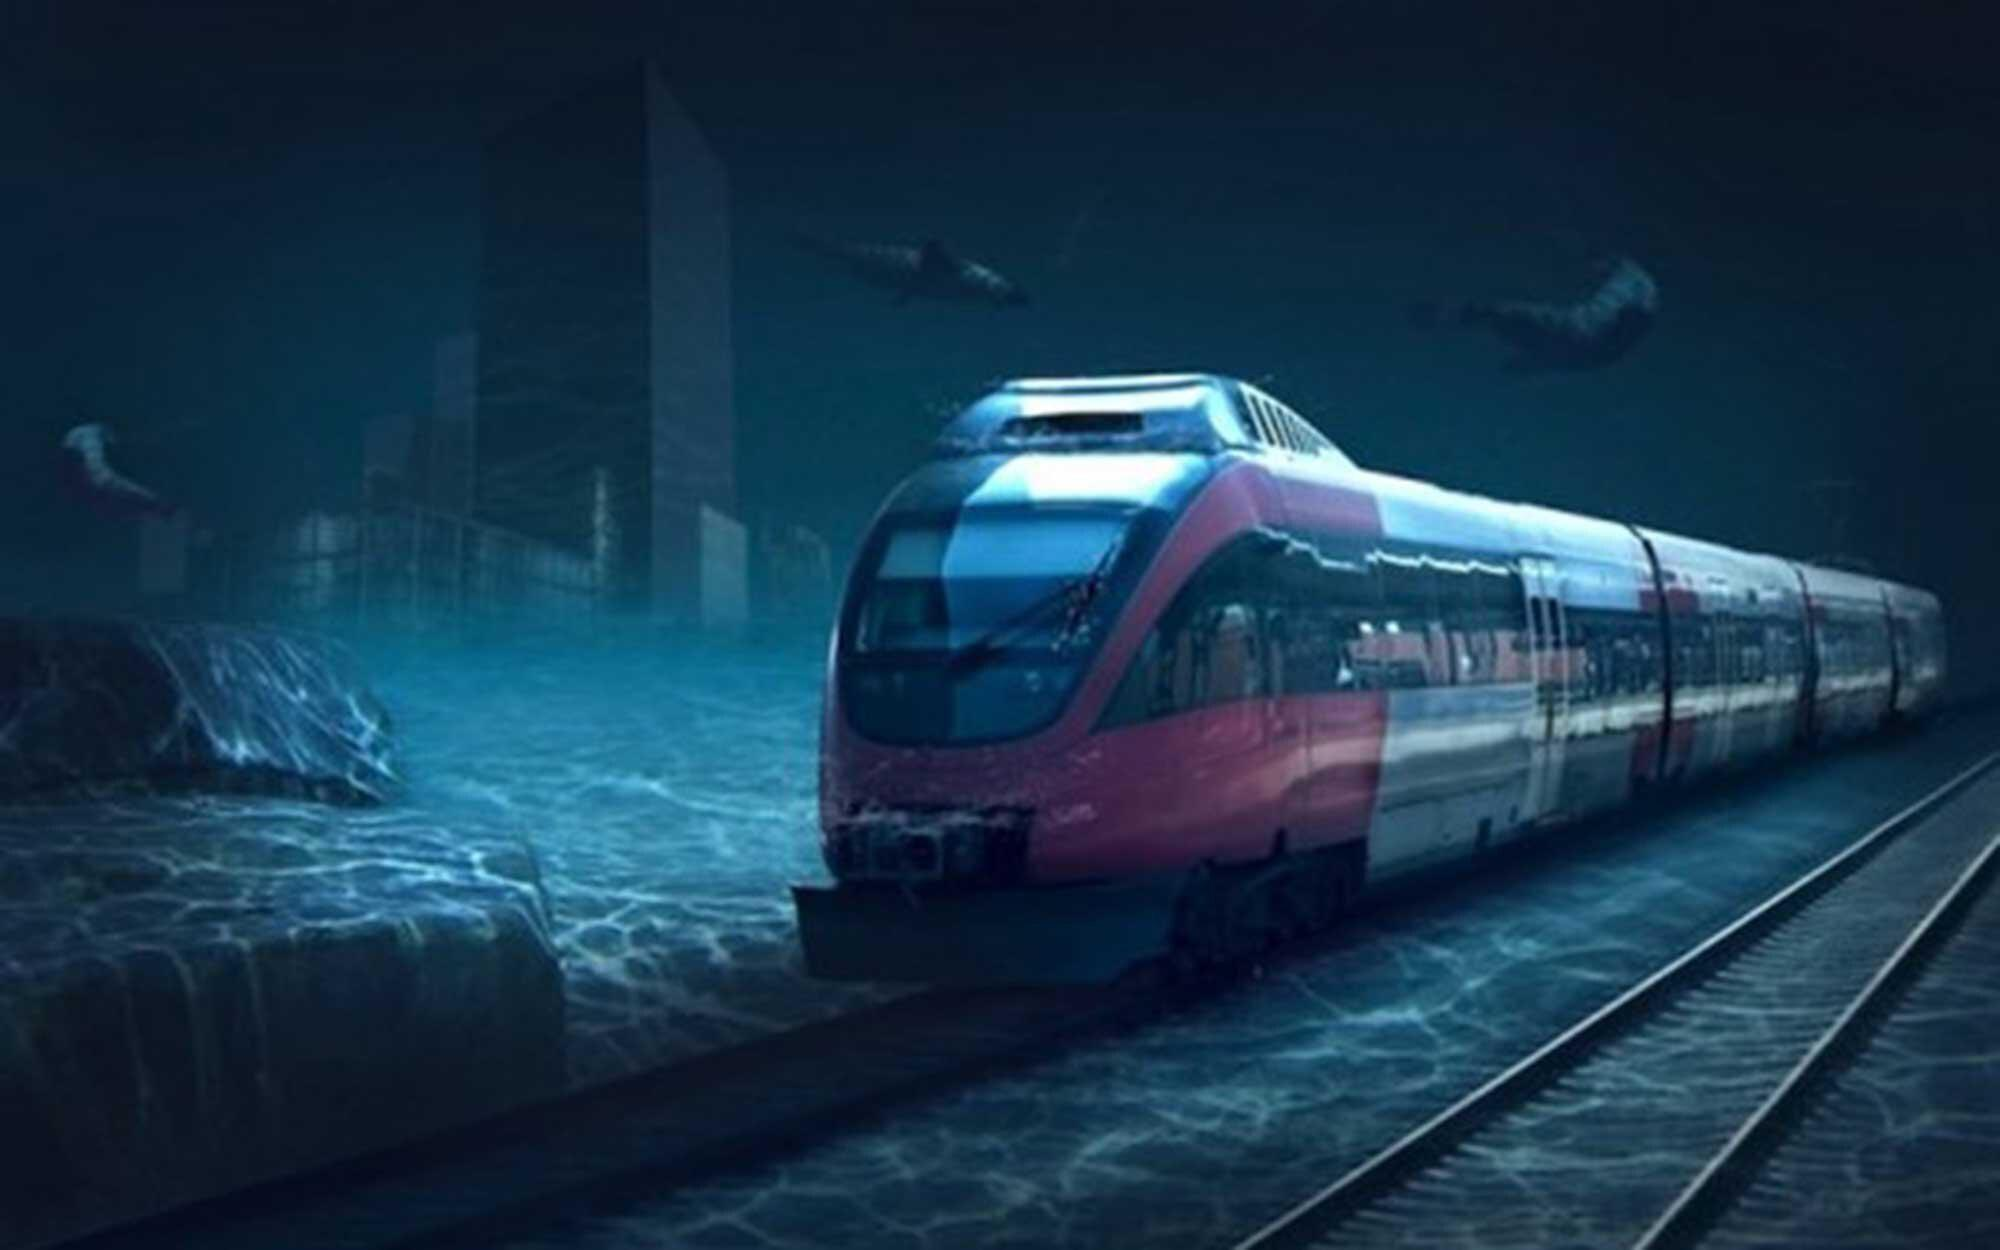How does the train appear to be operating in such an environment? The train in the image appears to be specially designed to function in this waterlogged urban environment. It may be waterproof and sealed against the elements, allowing it to travel efficiently despite the challenging conditions. The reflection off the train's surface indicates it's well-maintained, hinting at a world where humans have adapted to major geographical and climatic changes. 